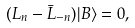Convert formula to latex. <formula><loc_0><loc_0><loc_500><loc_500>( L _ { n } - \bar { L } _ { - n } ) | B \rangle = 0 ,</formula> 